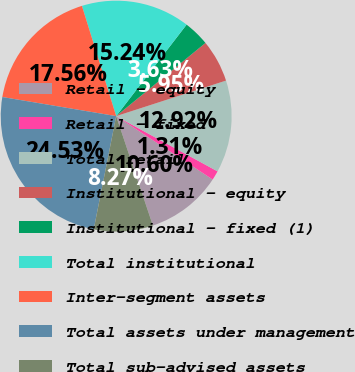Convert chart. <chart><loc_0><loc_0><loc_500><loc_500><pie_chart><fcel>Retail - equity<fcel>Retail - fixed<fcel>Total retail<fcel>Institutional - equity<fcel>Institutional - fixed (1)<fcel>Total institutional<fcel>Inter-segment assets<fcel>Total assets under management<fcel>Total sub-advised assets<nl><fcel>10.6%<fcel>1.31%<fcel>12.92%<fcel>5.95%<fcel>3.63%<fcel>15.24%<fcel>17.56%<fcel>24.53%<fcel>8.27%<nl></chart> 